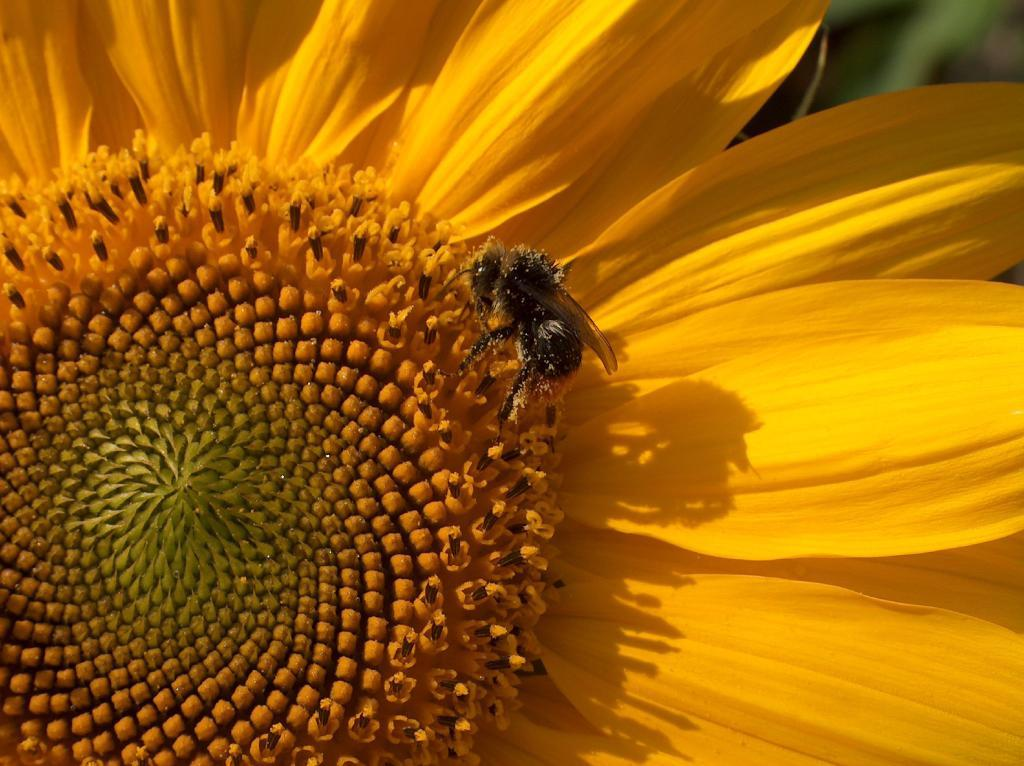What type of insect is present in the image? There is a bee in the image. What is the bee doing in the image? The bee is on a sunflower. What type of invention can be seen in the image? There is no invention present in the image; it features a bee on a sunflower. What sound can be heard coming from the bells in the image? There are no bells present in the image, so it's not possible to determine what sound might be heard. 